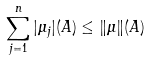Convert formula to latex. <formula><loc_0><loc_0><loc_500><loc_500>\sum _ { j = 1 } ^ { n } | \mu _ { j } | ( A ) \leq \| \mu \| ( A )</formula> 